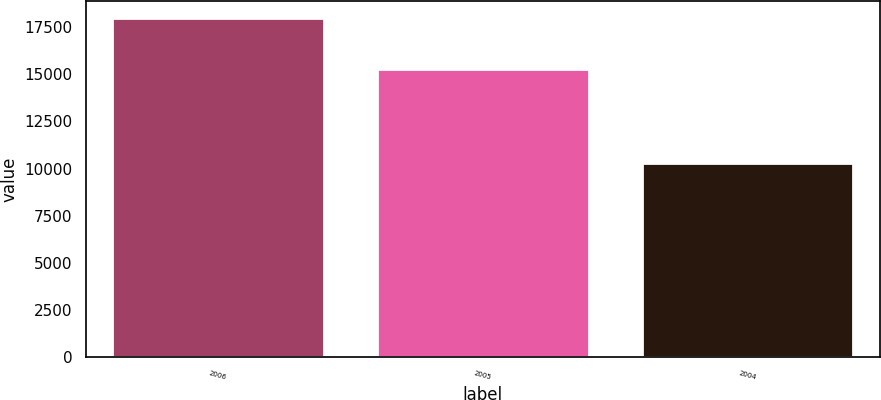<chart> <loc_0><loc_0><loc_500><loc_500><bar_chart><fcel>2006<fcel>2005<fcel>2004<nl><fcel>17992.7<fcel>15274.8<fcel>10296.4<nl></chart> 